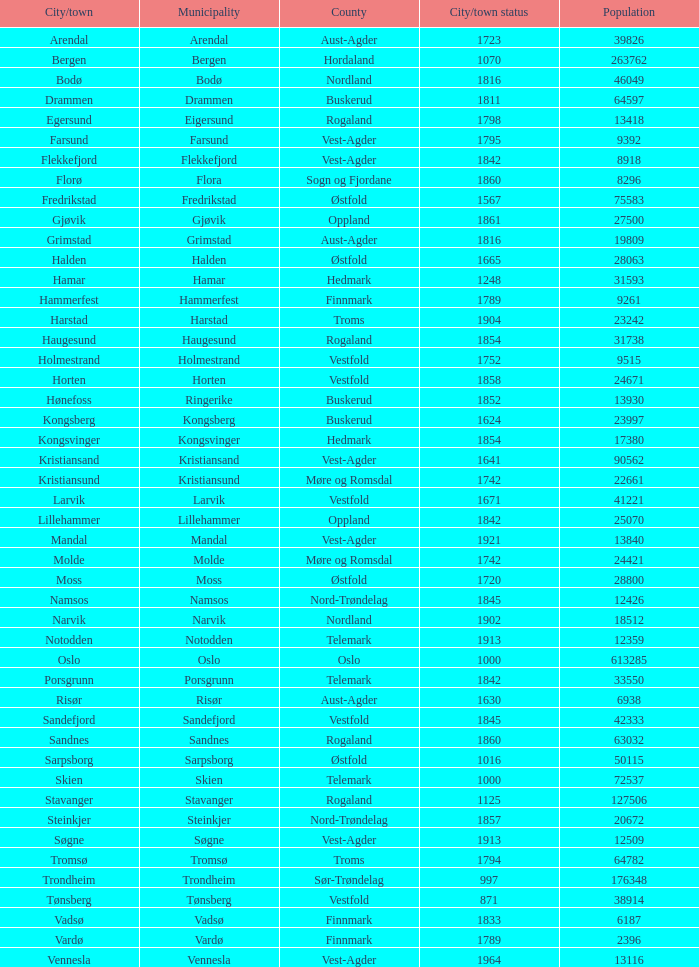Parse the full table. {'header': ['City/town', 'Municipality', 'County', 'City/town status', 'Population'], 'rows': [['Arendal', 'Arendal', 'Aust-Agder', '1723', '39826'], ['Bergen', 'Bergen', 'Hordaland', '1070', '263762'], ['Bodø', 'Bodø', 'Nordland', '1816', '46049'], ['Drammen', 'Drammen', 'Buskerud', '1811', '64597'], ['Egersund', 'Eigersund', 'Rogaland', '1798', '13418'], ['Farsund', 'Farsund', 'Vest-Agder', '1795', '9392'], ['Flekkefjord', 'Flekkefjord', 'Vest-Agder', '1842', '8918'], ['Florø', 'Flora', 'Sogn og Fjordane', '1860', '8296'], ['Fredrikstad', 'Fredrikstad', 'Østfold', '1567', '75583'], ['Gjøvik', 'Gjøvik', 'Oppland', '1861', '27500'], ['Grimstad', 'Grimstad', 'Aust-Agder', '1816', '19809'], ['Halden', 'Halden', 'Østfold', '1665', '28063'], ['Hamar', 'Hamar', 'Hedmark', '1248', '31593'], ['Hammerfest', 'Hammerfest', 'Finnmark', '1789', '9261'], ['Harstad', 'Harstad', 'Troms', '1904', '23242'], ['Haugesund', 'Haugesund', 'Rogaland', '1854', '31738'], ['Holmestrand', 'Holmestrand', 'Vestfold', '1752', '9515'], ['Horten', 'Horten', 'Vestfold', '1858', '24671'], ['Hønefoss', 'Ringerike', 'Buskerud', '1852', '13930'], ['Kongsberg', 'Kongsberg', 'Buskerud', '1624', '23997'], ['Kongsvinger', 'Kongsvinger', 'Hedmark', '1854', '17380'], ['Kristiansand', 'Kristiansand', 'Vest-Agder', '1641', '90562'], ['Kristiansund', 'Kristiansund', 'Møre og Romsdal', '1742', '22661'], ['Larvik', 'Larvik', 'Vestfold', '1671', '41221'], ['Lillehammer', 'Lillehammer', 'Oppland', '1842', '25070'], ['Mandal', 'Mandal', 'Vest-Agder', '1921', '13840'], ['Molde', 'Molde', 'Møre og Romsdal', '1742', '24421'], ['Moss', 'Moss', 'Østfold', '1720', '28800'], ['Namsos', 'Namsos', 'Nord-Trøndelag', '1845', '12426'], ['Narvik', 'Narvik', 'Nordland', '1902', '18512'], ['Notodden', 'Notodden', 'Telemark', '1913', '12359'], ['Oslo', 'Oslo', 'Oslo', '1000', '613285'], ['Porsgrunn', 'Porsgrunn', 'Telemark', '1842', '33550'], ['Risør', 'Risør', 'Aust-Agder', '1630', '6938'], ['Sandefjord', 'Sandefjord', 'Vestfold', '1845', '42333'], ['Sandnes', 'Sandnes', 'Rogaland', '1860', '63032'], ['Sarpsborg', 'Sarpsborg', 'Østfold', '1016', '50115'], ['Skien', 'Skien', 'Telemark', '1000', '72537'], ['Stavanger', 'Stavanger', 'Rogaland', '1125', '127506'], ['Steinkjer', 'Steinkjer', 'Nord-Trøndelag', '1857', '20672'], ['Søgne', 'Søgne', 'Vest-Agder', '1913', '12509'], ['Tromsø', 'Tromsø', 'Troms', '1794', '64782'], ['Trondheim', 'Trondheim', 'Sør-Trøndelag', '997', '176348'], ['Tønsberg', 'Tønsberg', 'Vestfold', '871', '38914'], ['Vadsø', 'Vadsø', 'Finnmark', '1833', '6187'], ['Vardø', 'Vardø', 'Finnmark', '1789', '2396'], ['Vennesla', 'Vennesla', 'Vest-Agder', '1964', '13116']]} Which towns situated in the finnmark county have populations larger than 618 Hammerfest. 